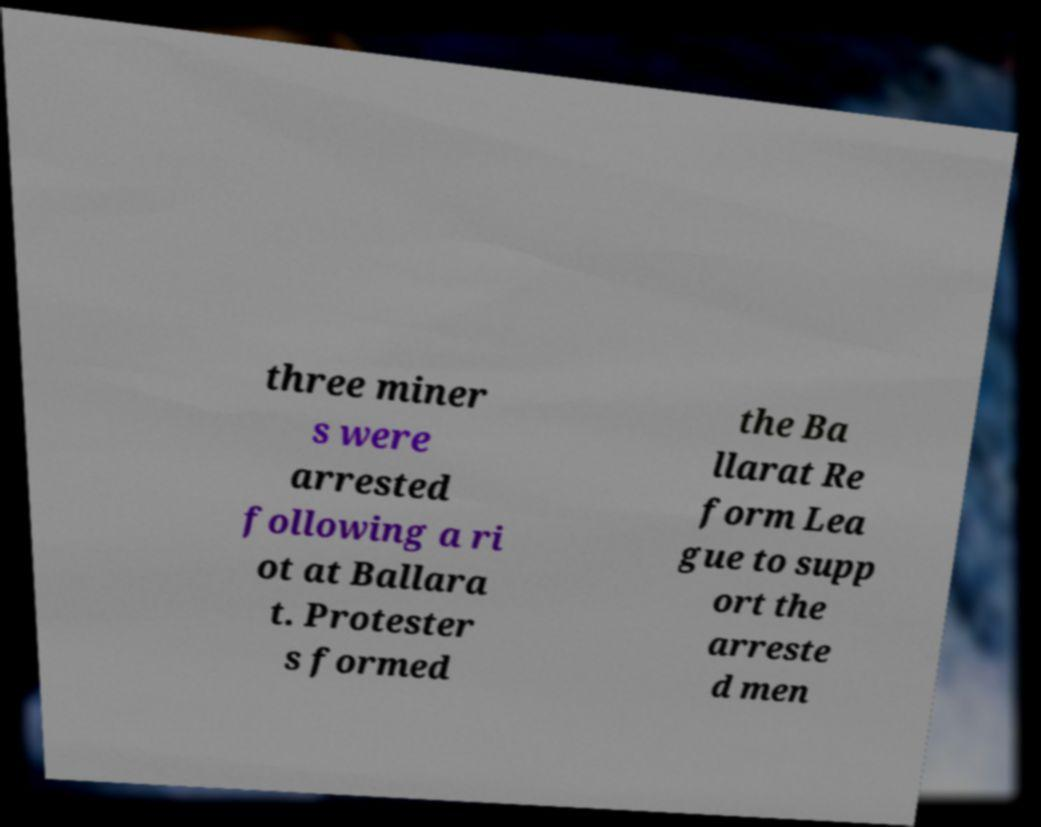Please read and relay the text visible in this image. What does it say? three miner s were arrested following a ri ot at Ballara t. Protester s formed the Ba llarat Re form Lea gue to supp ort the arreste d men 